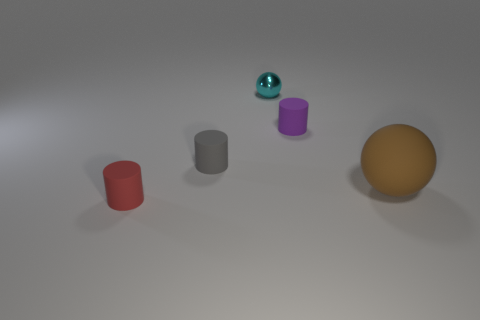Add 2 big green balls. How many objects exist? 7 Subtract all cylinders. How many objects are left? 2 Subtract 0 gray balls. How many objects are left? 5 Subtract all brown metal spheres. Subtract all tiny red things. How many objects are left? 4 Add 5 brown rubber things. How many brown rubber things are left? 6 Add 3 small brown cubes. How many small brown cubes exist? 3 